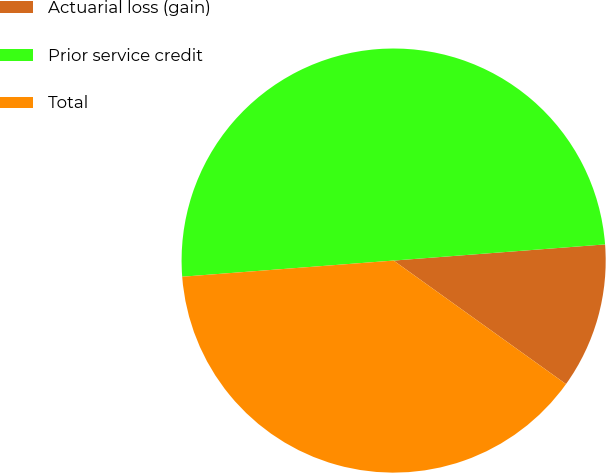Convert chart to OTSL. <chart><loc_0><loc_0><loc_500><loc_500><pie_chart><fcel>Actuarial loss (gain)<fcel>Prior service credit<fcel>Total<nl><fcel>11.11%<fcel>50.0%<fcel>38.89%<nl></chart> 